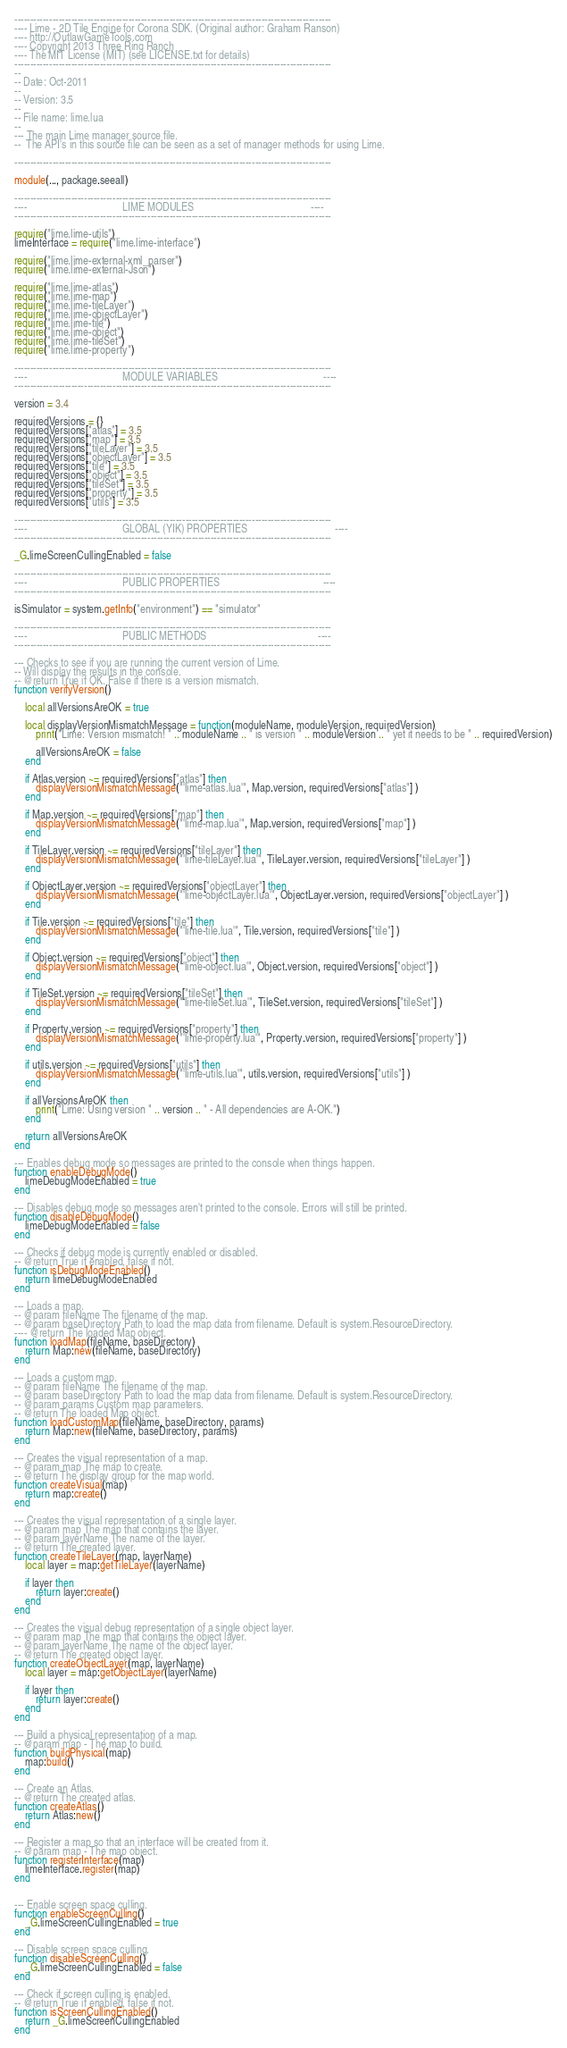Convert code to text. <code><loc_0><loc_0><loc_500><loc_500><_Lua_>----------------------------------------------------------------------------------------------------
---- Lime - 2D Tile Engine for Corona SDK. (Original author: Graham Ranson)
---- http://OutlawGameTools.com
---- Copyright 2013 Three Ring Ranch
---- The MIT License (MIT) (see LICENSE.txt for details)
----------------------------------------------------------------------------------------------------
--
-- Date: Oct-2011
--
-- Version: 3.5
--
-- File name: lime.lua
--
--- The main Lime manager source file.
--  The API's in this source file can be seen as a set of manager methods for using Lime.

----------------------------------------------------------------------------------------------------

module(..., package.seeall)

----------------------------------------------------------------------------------------------------
----									LIME MODULES											----
----------------------------------------------------------------------------------------------------

require("lime.lime-utils")
limeInterface = require("lime.lime-interface")

require("lime.lime-external-xml_parser")
require("lime.lime-external-Json")

require("lime.lime-atlas")
require("lime.lime-map")
require("lime.lime-tileLayer")
require("lime.lime-objectLayer")
require("lime.lime-tile")
require("lime.lime-object")
require("lime.lime-tileSet")
require("lime.lime-property")

----------------------------------------------------------------------------------------------------
----									MODULE VARIABLES										----
----------------------------------------------------------------------------------------------------

version = 3.4

requiredVersions = {}
requiredVersions["atlas"] = 3.5
requiredVersions["map"] = 3.5
requiredVersions["tileLayer"] = 3.5
requiredVersions["objectLayer"] = 3.5
requiredVersions["tile"] = 3.5
requiredVersions["object"] = 3.5
requiredVersions["tileSet"] = 3.5
requiredVersions["property"] = 3.5
requiredVersions["utils"] = 3.5

----------------------------------------------------------------------------------------------------
----									GLOBAL (YIK) PROPERTIES									----
----------------------------------------------------------------------------------------------------

_G.limeScreenCullingEnabled = false

----------------------------------------------------------------------------------------------------
----									PUBLIC PROPERTIES										----
----------------------------------------------------------------------------------------------------

isSimulator = system.getInfo("environment") == "simulator"

----------------------------------------------------------------------------------------------------
----									PUBLIC METHODS										    ----
----------------------------------------------------------------------------------------------------

--- Checks to see if you are running the current version of Lime. 
-- Will display the results in the console.
-- @return True if OK. False if there is a version mismatch.
function verifyVersion()
	
	local allVersionsAreOK = true
	
	local displayVersionMismatchMessage = function(moduleName, moduleVersion, requiredVersion)
		print("Lime: Version mismatch! " .. moduleName .. " is version " .. moduleVersion .. " yet it needs to be " .. requiredVersion)
		
		allVersionsAreOK = false
	end

	if Atlas.version ~= requiredVersions["atlas"] then
		displayVersionMismatchMessage("'lime-atlas.lua'", Map.version, requiredVersions["atlas"] )
	end
	
	if Map.version ~= requiredVersions["map"] then
		displayVersionMismatchMessage("'lime-map.lua'", Map.version, requiredVersions["map"] )
	end
	
	if TileLayer.version ~= requiredVersions["tileLayer"] then
		displayVersionMismatchMessage("'lime-tileLayer.lua'", TileLayer.version, requiredVersions["tileLayer"] )
	end
	
	if ObjectLayer.version ~= requiredVersions["objectLayer"] then
		displayVersionMismatchMessage("'lime-objectLayer.lua'", ObjectLayer.version, requiredVersions["objectLayer"] )
	end
	
	if Tile.version ~= requiredVersions["tile"] then
		displayVersionMismatchMessage("'lime-tile.lua'", Tile.version, requiredVersions["tile"] )
	end
	
	if Object.version ~= requiredVersions["object"] then
		displayVersionMismatchMessage("'lime-object.lua'", Object.version, requiredVersions["object"] )
	end
	
	if TileSet.version ~= requiredVersions["tileSet"] then
		displayVersionMismatchMessage("'lime-tileSet.lua'", TileSet.version, requiredVersions["tileSet"] )
	end
	
	if Property.version ~= requiredVersions["property"] then
		displayVersionMismatchMessage("'lime-property.lua'", Property.version, requiredVersions["property"] )
	end	
	
	if utils.version ~= requiredVersions["utils"] then
		displayVersionMismatchMessage("'lime-utils.lua'", utils.version, requiredVersions["utils"] )
	end			

	if allVersionsAreOK then
		print("Lime: Using version " .. version .. " - All dependencies are A-OK.")
	end
	
	return allVersionsAreOK
end

--- Enables debug mode so messages are printed to the console when things happen.
function enableDebugMode()
	limeDebugModeEnabled = true
end

--- Disables debug mode so messages aren't printed to the console. Errors will still be printed.
function disableDebugMode()
	limeDebugModeEnabled = false
end	

--- Checks if debug mode is currently enabled or disabled.
-- @return True if enabled, false if not.
function isDebugModeEnabled()
	return limeDebugModeEnabled
end

--- Loads a map.
-- @param fileName The filename of the map.
-- @param baseDirectory Path to load the map data from filename. Default is system.ResourceDirectory.
---- @return The loaded Map object.
function loadMap(fileName, baseDirectory)
	return Map:new(fileName, baseDirectory)	
end

--- Loads a custom map.
-- @param fileName The filename of the map.
-- @param baseDirectory Path to load the map data from filename. Default is system.ResourceDirectory.
-- @param params Custom map parameters.
-- @return The loaded Map object.
function loadCustomMap(fileName, baseDirectory, params)
	return Map:new(fileName, baseDirectory, params)	
end

--- Creates the visual representation of a map.
-- @param map The map to create.
-- @return The display group for the map world.
function createVisual(map)
	return map:create()
end

--- Creates the visual representation of a single layer.
-- @param map The map that contains the layer.
-- @param layerName The name of the layer.
-- @return The created layer.
function createTileLayer(map, layerName)
	local layer = map:getTileLayer(layerName)
	
	if layer then
		return layer:create()
	end
end

--- Creates the visual debug representation of a single object layer.
-- @param map The map that contains the object layer.
-- @param layerName The name of the object layer.
-- @return The created object layer.
function createObjectLayer(map, layerName)
	local layer = map:getObjectLayer(layerName)
	
	if layer then
		return layer:create()
	end
end

--- Build a physical representation of a map.
-- @param map - The map to build. 
function buildPhysical(map)
	map:build()
end

--- Create an Atlas.
-- @return The created atlas.
function createAtlas()
	return Atlas:new()
end

--- Register a map so that an interface will be created from it.
-- @param map - The map object. 
function registerInterface(map)
	limeInterface.register(map)
end


--- Enable screen space culling.
function enableScreenCulling()
	_G.limeScreenCullingEnabled = true
end

--- Disable screen space culling.
function disableScreenCulling()
	_G.limeScreenCullingEnabled = false
end	

--- Check if screen culling is enabled.
-- @return True if enabled, false if not.
function isScreenCullingEnabled()
	return _G.limeScreenCullingEnabled
end
</code> 